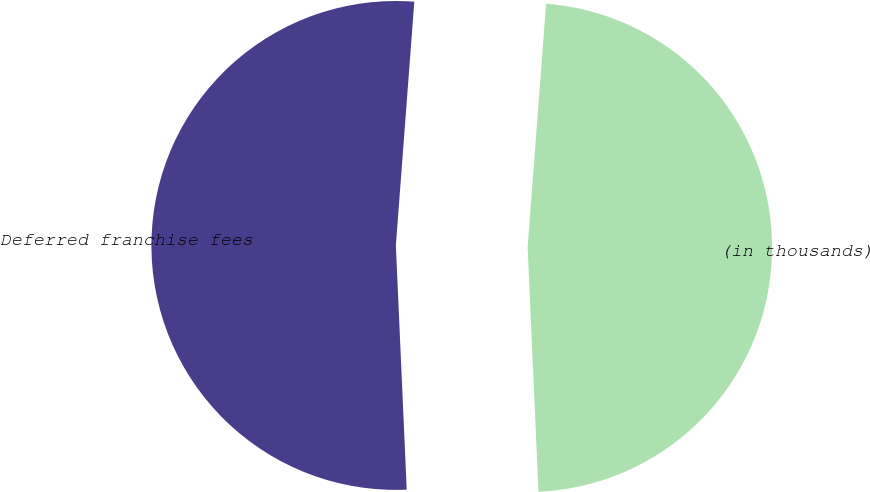Convert chart to OTSL. <chart><loc_0><loc_0><loc_500><loc_500><pie_chart><fcel>(in thousands)<fcel>Deferred franchise fees<nl><fcel>48.09%<fcel>51.91%<nl></chart> 